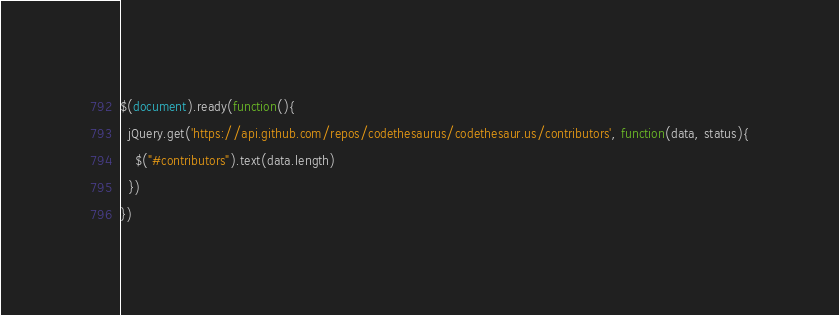Convert code to text. <code><loc_0><loc_0><loc_500><loc_500><_JavaScript_>$(document).ready(function(){
  jQuery.get('https://api.github.com/repos/codethesaurus/codethesaur.us/contributors', function(data, status){
    $("#contributors").text(data.length)
  })
})</code> 